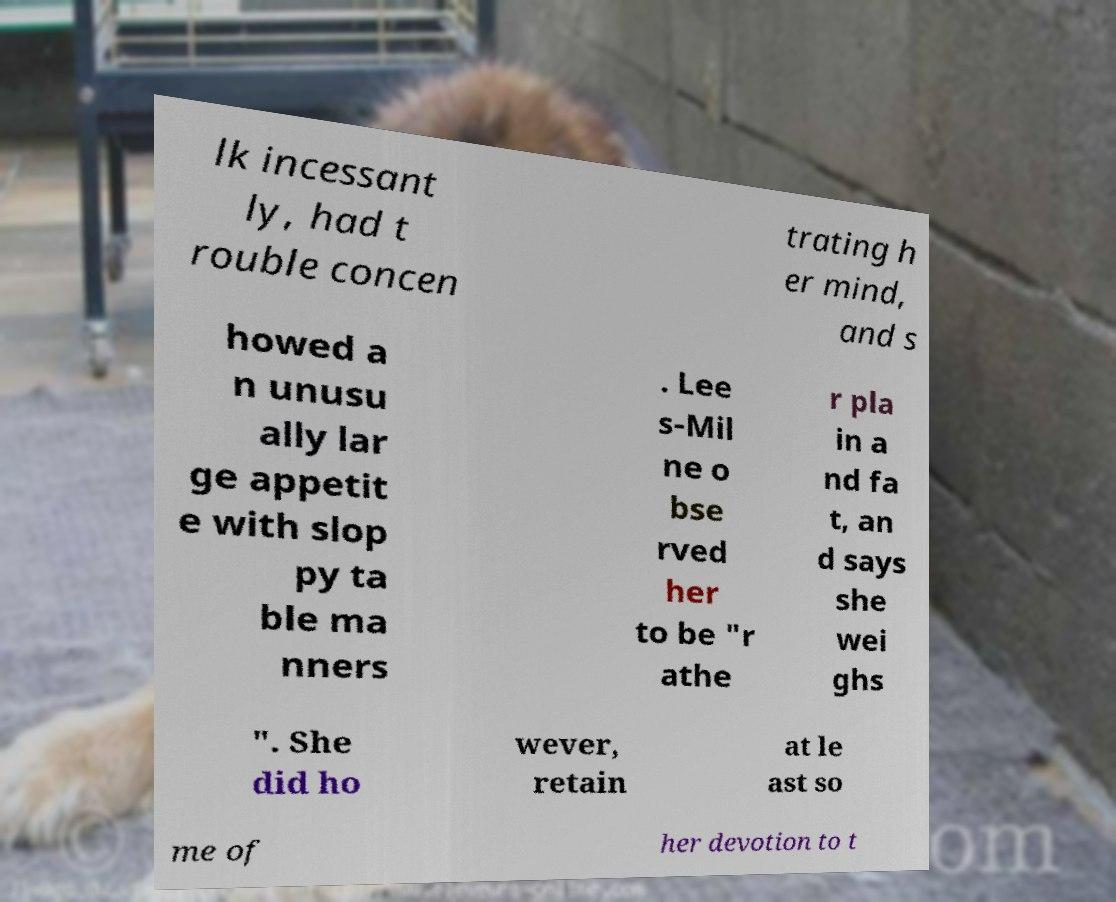Can you read and provide the text displayed in the image?This photo seems to have some interesting text. Can you extract and type it out for me? lk incessant ly, had t rouble concen trating h er mind, and s howed a n unusu ally lar ge appetit e with slop py ta ble ma nners . Lee s-Mil ne o bse rved her to be "r athe r pla in a nd fa t, an d says she wei ghs ". She did ho wever, retain at le ast so me of her devotion to t 